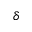<formula> <loc_0><loc_0><loc_500><loc_500>\delta</formula> 